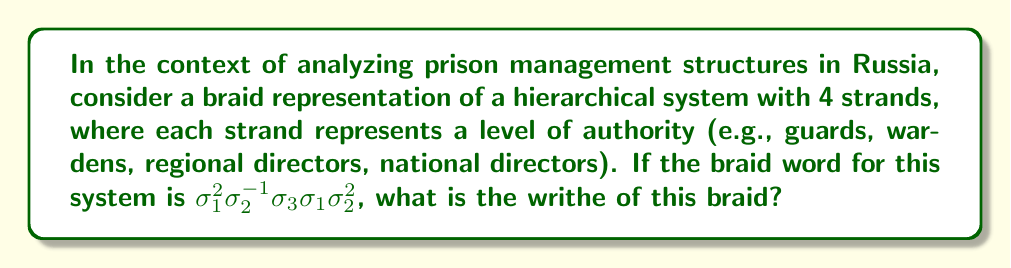Could you help me with this problem? To calculate the writhe of the braid, we need to follow these steps:

1) Recall that the writhe is the sum of the signs of all crossings in the braid diagram.

2) In braid notation:
   - $\sigma_i$ represents a positive crossing (writhe +1)
   - $\sigma_i^{-1}$ represents a negative crossing (writhe -1)

3) Let's analyze each term in the braid word $\sigma_1^2\sigma_2^{-1}\sigma_3\sigma_1\sigma_2^2$:

   - $\sigma_1^2$: Two positive crossings, contribution: +2
   - $\sigma_2^{-1}$: One negative crossing, contribution: -1
   - $\sigma_3$: One positive crossing, contribution: +1
   - $\sigma_1$: One positive crossing, contribution: +1
   - $\sigma_2^2$: Two positive crossings, contribution: +2

4) Sum up all contributions:
   
   $$(+2) + (-1) + (+1) + (+1) + (+2) = 5$$

Thus, the writhe of this braid is 5.

This positive writhe suggests a generally top-down, hierarchical structure in the Russian prison management system, with more instances of authority being passed down (positive crossings) than up (negative crossings).
Answer: 5 